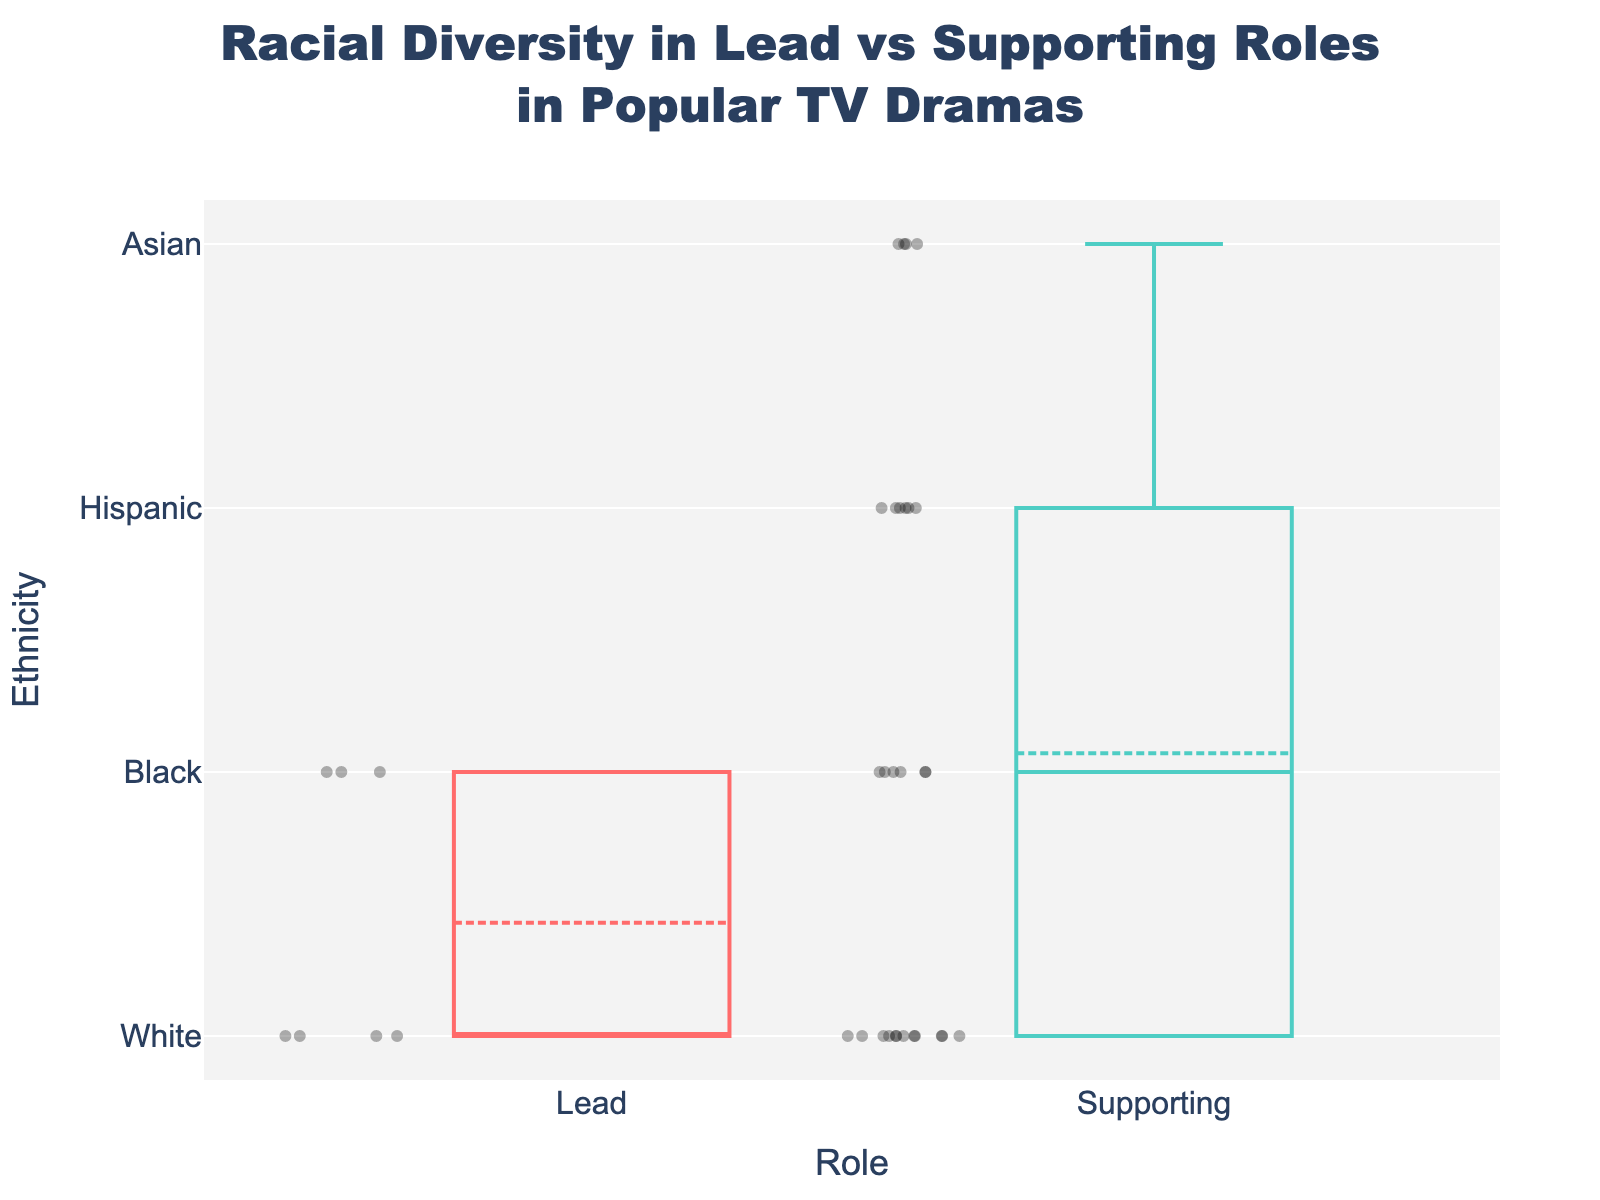What is the title of the figure? The title is located at the top of the figure and reads "Racial Diversity in Lead vs Supporting Roles in Popular TV Dramas".
Answer: Racial Diversity in Lead vs Supporting Roles in Popular TV Dramas How many ethnic categories are displayed on the y-axis? By counting the labels on the y-axis, we see "White," "Black," "Hispanic," and "Asian."
Answer: 4 What roles are being compared in the figure? The x-axis has two categories used for comparison: 'Lead' and 'Supporting'.
Answer: Lead and Supporting Which ethnicity appears most frequently in the Lead role category? By observing the scatter points in the 'Lead' box plot, 'White' appears more frequently than other ethnicities.
Answer: White Which role has more diversity in ethnic representation? By comparing the scatter points in both 'Lead' and 'Supporting' box plots, the 'Supporting' role shows more diversity with points scattered across all four ethnic categories.
Answer: Supporting What is the color used for the box plot lines of Lead roles? The color of the box plot lines for Lead roles is given by '#FF6B6B', which is a shade of red.
Answer: Red How many Lead characters are black in the figure? By counting the scatter points for 'Black' under the 'Lead' role category, there are two points.
Answer: 2 Compare the median ethnicity of Lead and Supporting roles. The median is represented by the line inside the box. For Lead roles, the median is at 'White,' while for Supporting roles, it appears to be between 'White' and 'Black.'
Answer: Lead: White, Supporting: Between White and Black Is there an ethnic category that does not appear in the Lead roles? By checking scatter points in the 'Lead' role box plot, 'Asian' and 'Hispanic' are missing.
Answer: Asian and Hispanic What is the relative frequency of White characters in Supporting roles compared to Lead roles? By counting the scatter points, we see that there are 11 White characters in Supporting roles and 3 in Lead roles. Therefore, White characters are more frequent in Supporting roles.
Answer: More frequent in Supporting roles 